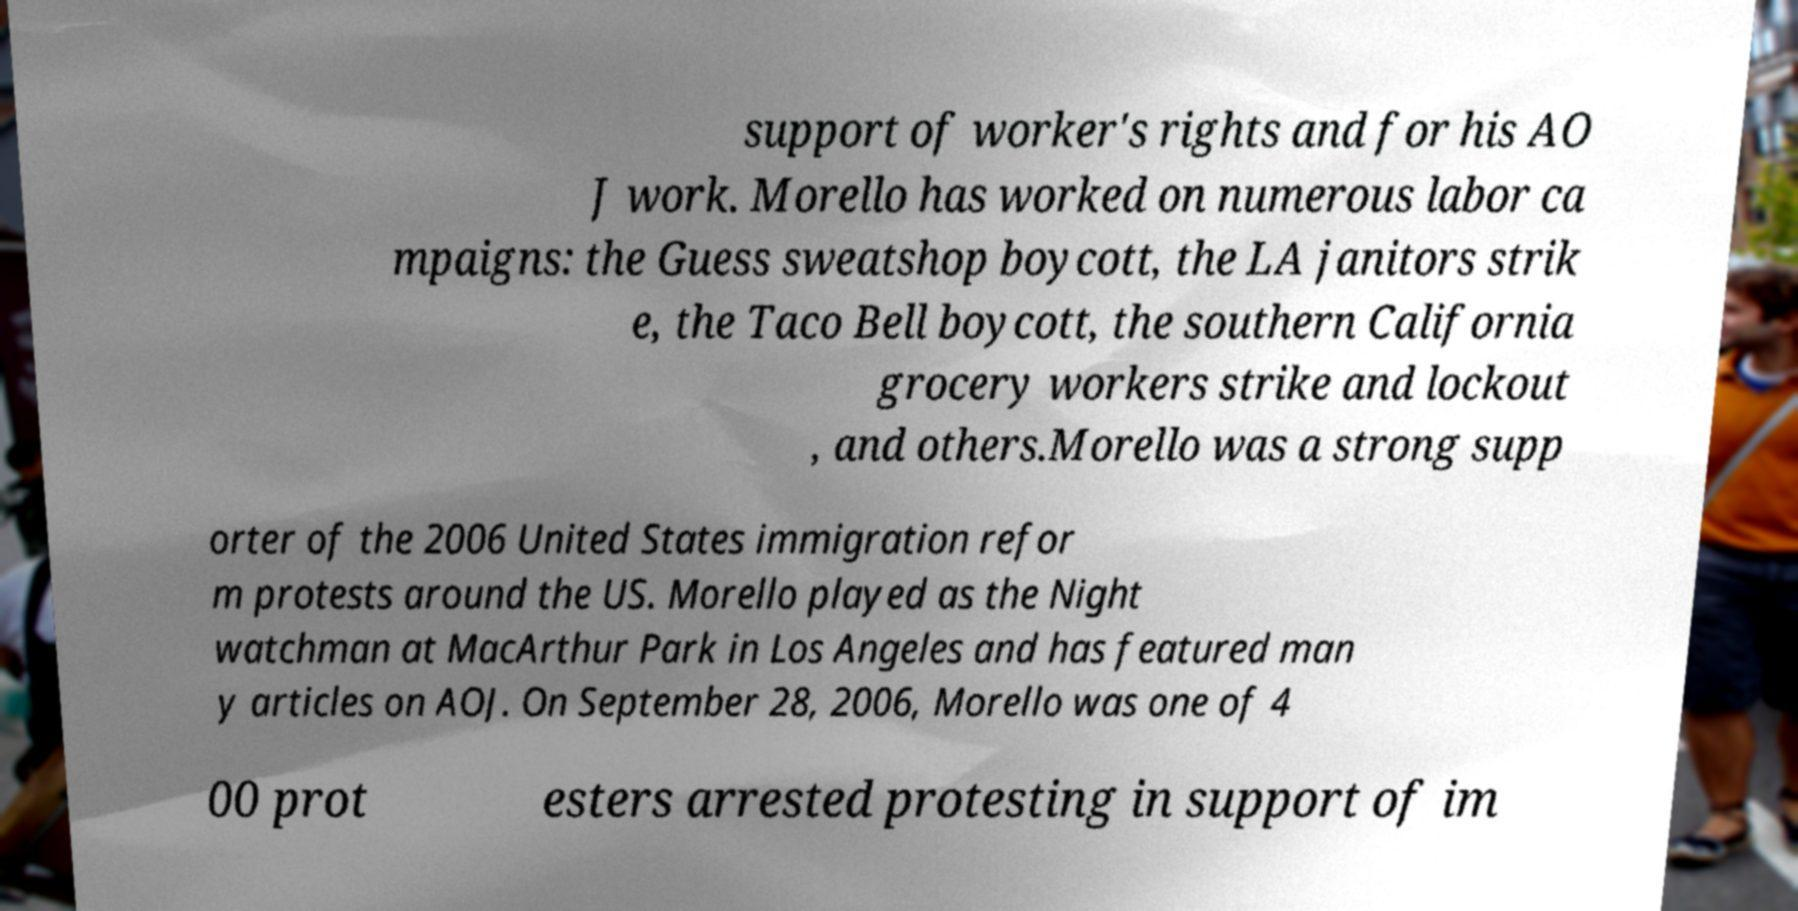For documentation purposes, I need the text within this image transcribed. Could you provide that? support of worker's rights and for his AO J work. Morello has worked on numerous labor ca mpaigns: the Guess sweatshop boycott, the LA janitors strik e, the Taco Bell boycott, the southern California grocery workers strike and lockout , and others.Morello was a strong supp orter of the 2006 United States immigration refor m protests around the US. Morello played as the Night watchman at MacArthur Park in Los Angeles and has featured man y articles on AOJ. On September 28, 2006, Morello was one of 4 00 prot esters arrested protesting in support of im 